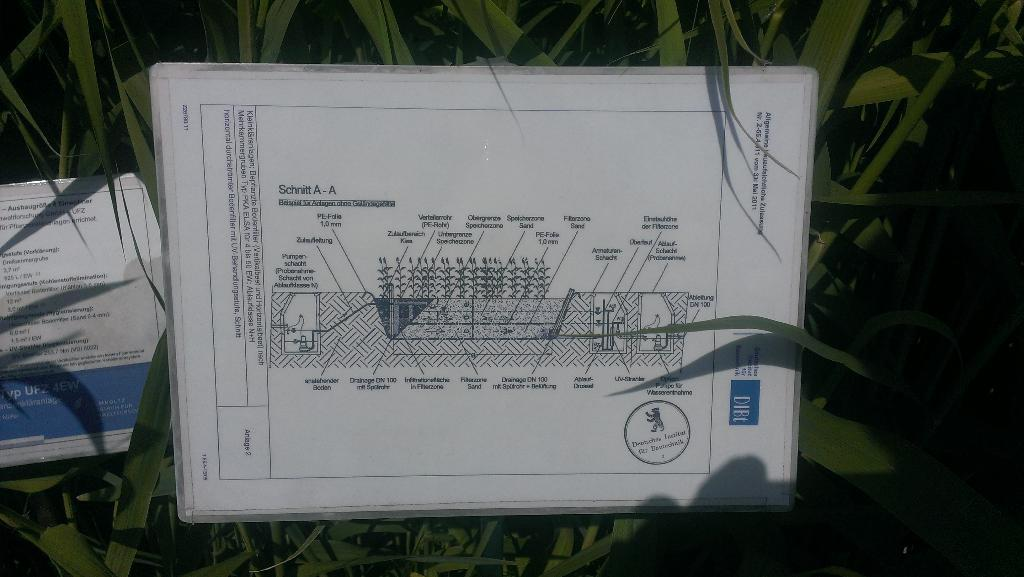What is the main object in the center of the image? There is a board in the center of the image. What can be found on the board? There is text on the board. Are there any other boards in the image? Yes, there is another board beside the first board. What can be seen in the background of the image? There are plants visible in the background of the image. What type of glue is being used to attach the toy cars to the board in the image? There are no toy cars or glue present in the image; it only features boards with text and plants in the background. 